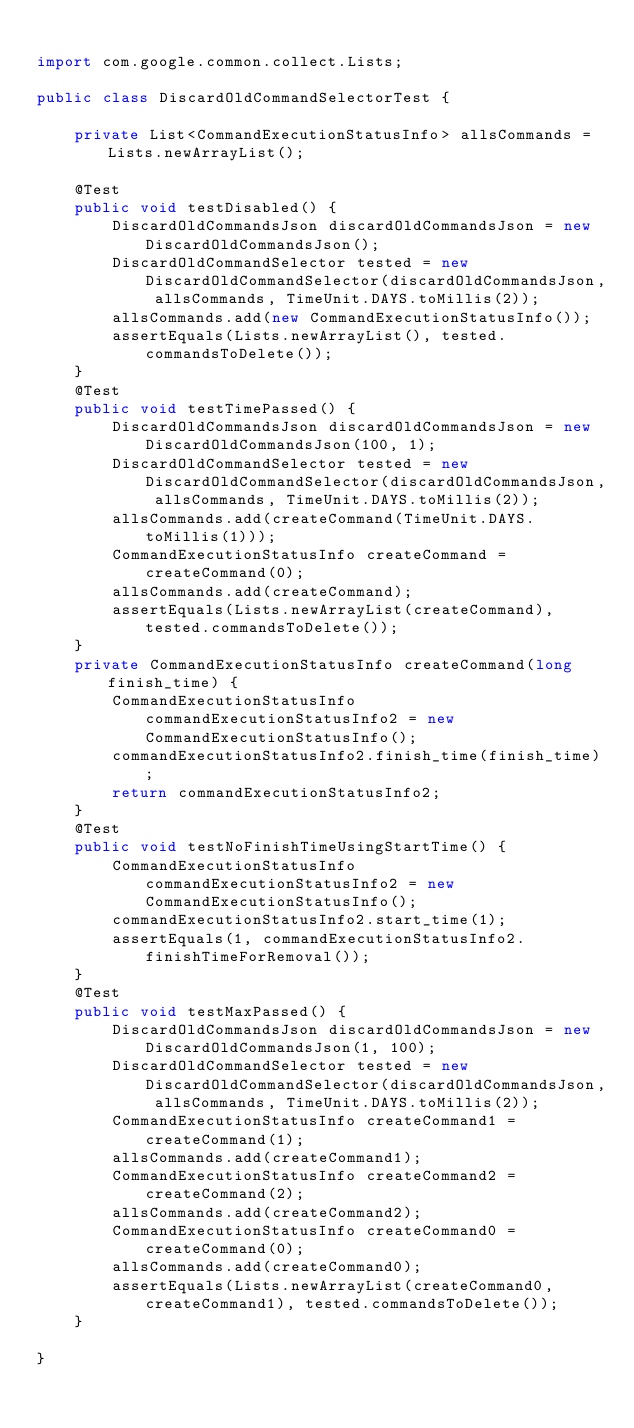<code> <loc_0><loc_0><loc_500><loc_500><_Java_>
import com.google.common.collect.Lists;

public class DiscardOldCommandSelectorTest {

	private List<CommandExecutionStatusInfo> allsCommands = Lists.newArrayList();
	
	@Test
	public void testDisabled() {
		DiscardOldCommandsJson discardOldCommandsJson = new DiscardOldCommandsJson();
		DiscardOldCommandSelector tested = new DiscardOldCommandSelector(discardOldCommandsJson, allsCommands, TimeUnit.DAYS.toMillis(2));
		allsCommands.add(new CommandExecutionStatusInfo());
		assertEquals(Lists.newArrayList(), tested.commandsToDelete());
	}
	@Test
	public void testTimePassed() {
		DiscardOldCommandsJson discardOldCommandsJson = new DiscardOldCommandsJson(100, 1);
		DiscardOldCommandSelector tested = new DiscardOldCommandSelector(discardOldCommandsJson, allsCommands, TimeUnit.DAYS.toMillis(2));
		allsCommands.add(createCommand(TimeUnit.DAYS.toMillis(1)));
		CommandExecutionStatusInfo createCommand = createCommand(0);
		allsCommands.add(createCommand);
		assertEquals(Lists.newArrayList(createCommand), tested.commandsToDelete());
	}
	private CommandExecutionStatusInfo createCommand(long finish_time) {
		CommandExecutionStatusInfo commandExecutionStatusInfo2 = new CommandExecutionStatusInfo();
		commandExecutionStatusInfo2.finish_time(finish_time);
		return commandExecutionStatusInfo2;
	}
	@Test
	public void testNoFinishTimeUsingStartTime() {
		CommandExecutionStatusInfo commandExecutionStatusInfo2 = new CommandExecutionStatusInfo();
		commandExecutionStatusInfo2.start_time(1);
		assertEquals(1, commandExecutionStatusInfo2.finishTimeForRemoval());
	}
	@Test
	public void testMaxPassed() {
		DiscardOldCommandsJson discardOldCommandsJson = new DiscardOldCommandsJson(1, 100);
		DiscardOldCommandSelector tested = new DiscardOldCommandSelector(discardOldCommandsJson, allsCommands, TimeUnit.DAYS.toMillis(2));
		CommandExecutionStatusInfo createCommand1 = createCommand(1);
		allsCommands.add(createCommand1);
		CommandExecutionStatusInfo createCommand2 = createCommand(2);
		allsCommands.add(createCommand2);
		CommandExecutionStatusInfo createCommand0 = createCommand(0);
		allsCommands.add(createCommand0);
		assertEquals(Lists.newArrayList(createCommand0, createCommand1), tested.commandsToDelete());
	}

}
</code> 